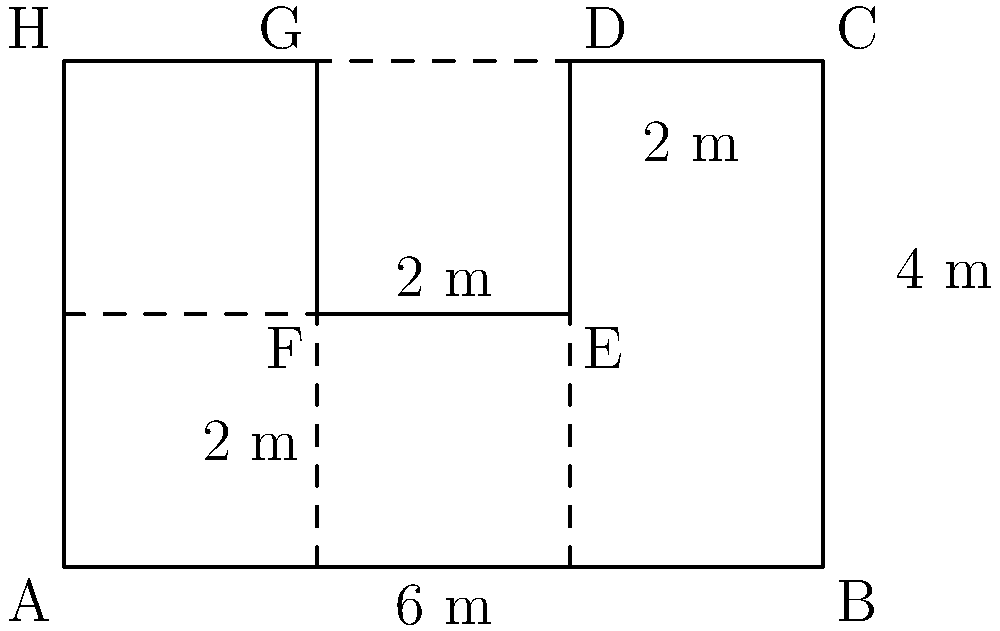During your research on the industrial revolution in Manchester, you come across a map of an irregularly shaped industrial plot. The plot is represented by the shape ABCDEFGH in the diagram. Given that each small square represents 1 square meter, calculate the perimeter of this industrial plot in meters. To find the perimeter, we need to sum up the lengths of all sides of the irregular shape. Let's break it down step-by-step:

1) Side AB: 6 meters (given in the diagram)
2) Side BC: 4 meters (given in the diagram)
3) Side CD: 2 meters (count the small squares)
4) Side DE: 2 meters (given in the diagram)
5) Side EF: 2 meters (count the small squares)
6) Side FG: 2 meters (count the small squares)
7) Side GH: 2 meters (count the small squares)
8) Side HA: 4 meters (given in the diagram)

Now, let's sum up all these lengths:

$$ \text{Perimeter} = 6 + 4 + 2 + 2 + 2 + 2 + 2 + 4 = 24 $$

Therefore, the perimeter of the industrial plot is 24 meters.
Answer: 24 meters 